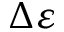<formula> <loc_0><loc_0><loc_500><loc_500>\Delta \varepsilon</formula> 